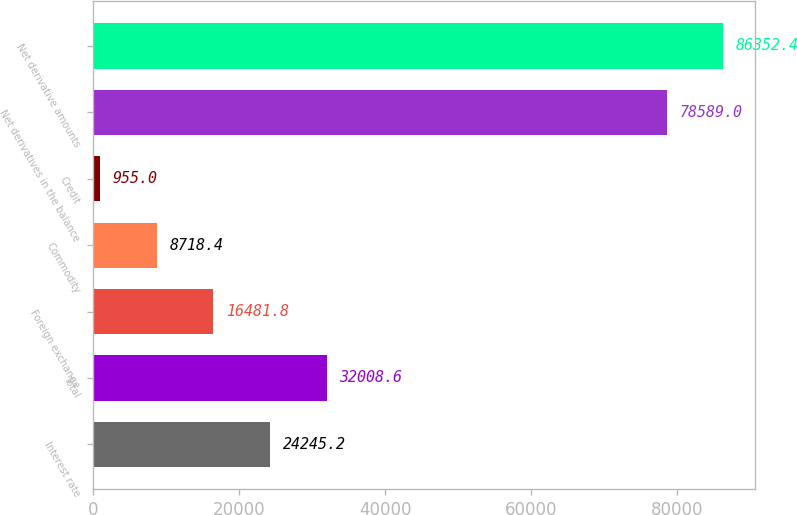Convert chart. <chart><loc_0><loc_0><loc_500><loc_500><bar_chart><fcel>Interest rate<fcel>Total<fcel>Foreign exchange<fcel>Commodity<fcel>Credit<fcel>Net derivatives in the balance<fcel>Net derivative amounts<nl><fcel>24245.2<fcel>32008.6<fcel>16481.8<fcel>8718.4<fcel>955<fcel>78589<fcel>86352.4<nl></chart> 